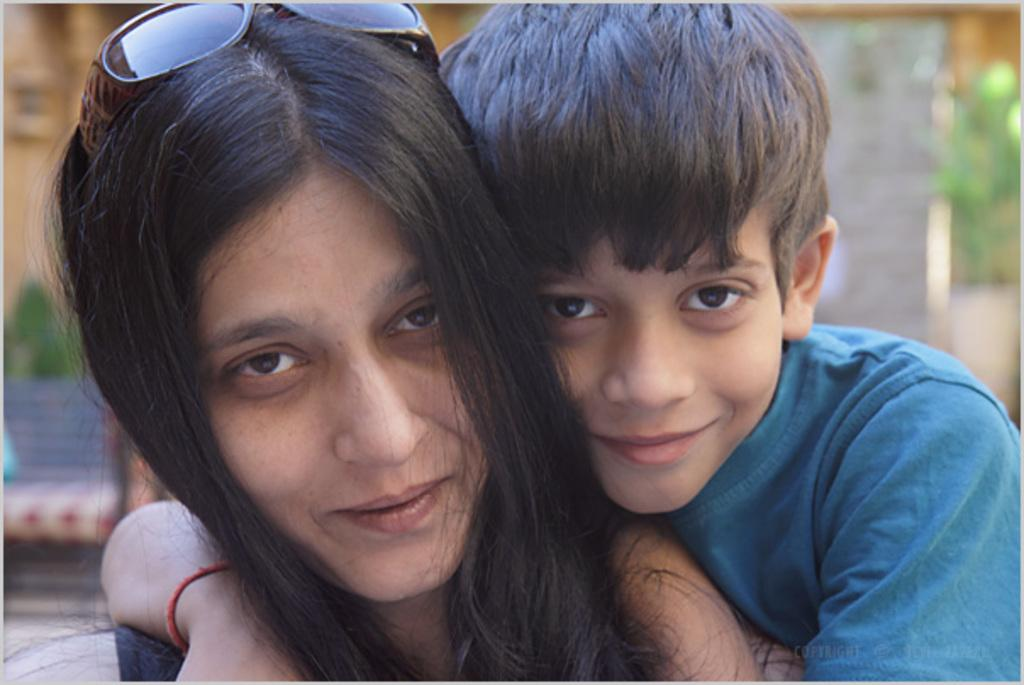Who are the people in the image? There is a woman and a boy in the image. What are the expressions on their faces? Both the woman and the boy are smiling. What is the woman wearing on her head? The woman is wearing goggles on her head. What can be seen in the background of the image? There is a bench and a wall in the background of the image. What time is the nut shown in the image? There is no nut present in the image. Who is the creator of the wall in the background? The image does not provide information about the creator of the wall. 